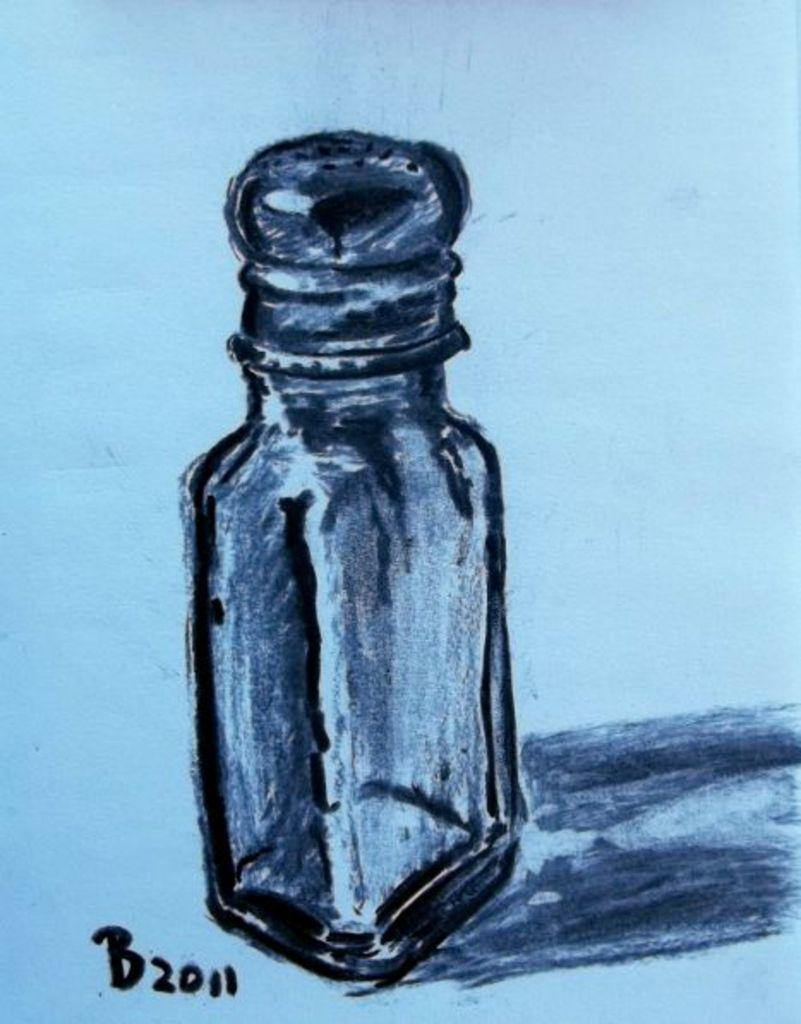Provide a one-sentence caption for the provided image. A drawing of a salt shaker with the date 2011. 